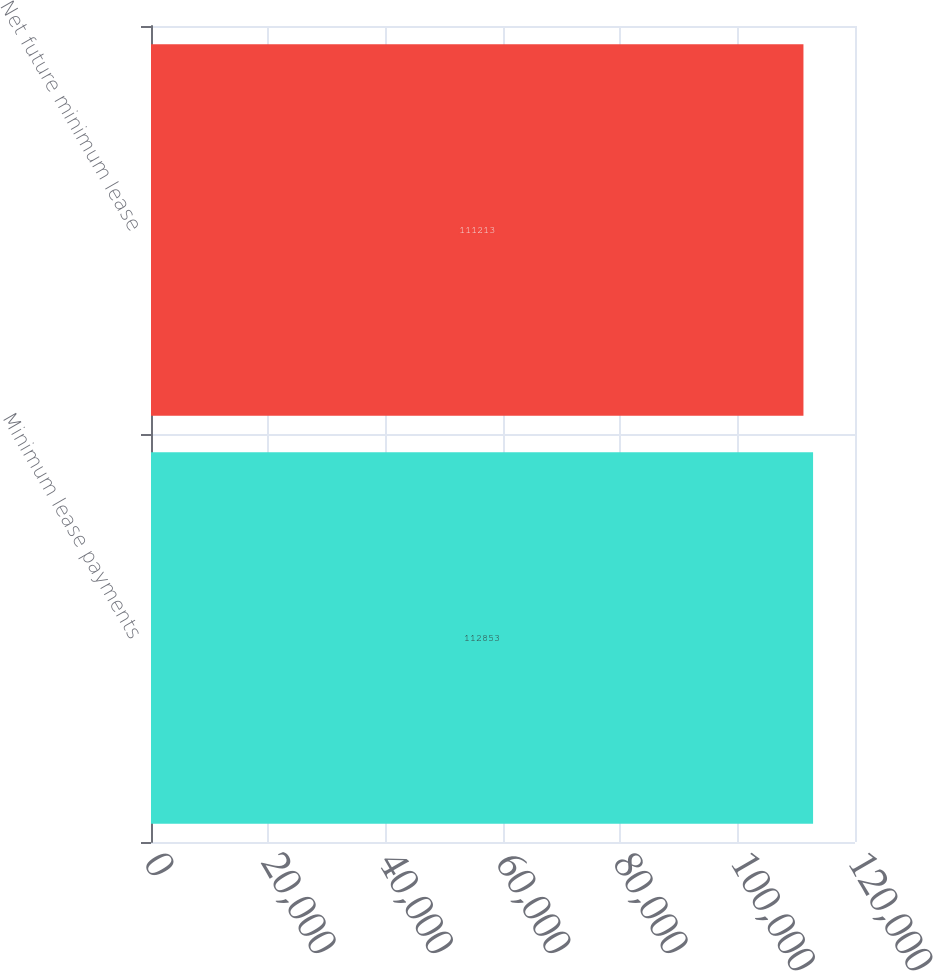Convert chart to OTSL. <chart><loc_0><loc_0><loc_500><loc_500><bar_chart><fcel>Minimum lease payments<fcel>Net future minimum lease<nl><fcel>112853<fcel>111213<nl></chart> 